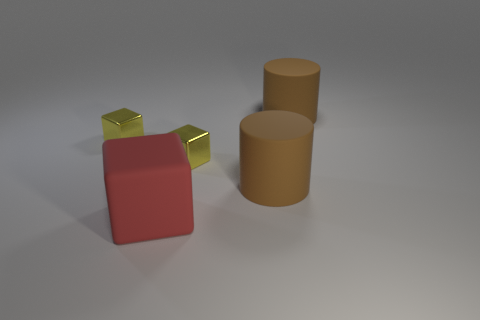There is a yellow block that is right of the matte cube; is it the same size as the big red object?
Your answer should be very brief. No. What shape is the small object to the left of the big red rubber block?
Keep it short and to the point. Cube. Are there more yellow objects than large red cubes?
Offer a terse response. Yes. Is the color of the small object that is to the left of the red thing the same as the rubber cube?
Make the answer very short. No. How many things are either small yellow blocks on the right side of the large red matte cube or rubber things to the right of the big red rubber object?
Offer a very short reply. 3. What number of blocks are on the left side of the big red thing and on the right side of the red rubber block?
Offer a terse response. 0. The tiny yellow shiny thing that is behind the tiny block that is to the right of the small thing left of the red block is what shape?
Offer a terse response. Cube. The large matte cylinder on the right side of the brown thing that is in front of the metallic block that is on the right side of the rubber block is what color?
Your answer should be very brief. Brown. How many blue things are big blocks or large objects?
Ensure brevity in your answer.  0. How many other things are the same size as the red rubber block?
Offer a very short reply. 2. 